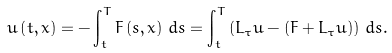<formula> <loc_0><loc_0><loc_500><loc_500>u \left ( t , x \right ) = - \int _ { t } ^ { T } F \left ( s , x \right ) \, d s = \int _ { t } ^ { T } \left ( L _ { \tau } u - ( F + L _ { \tau } u ) \right ) \, d s .</formula> 